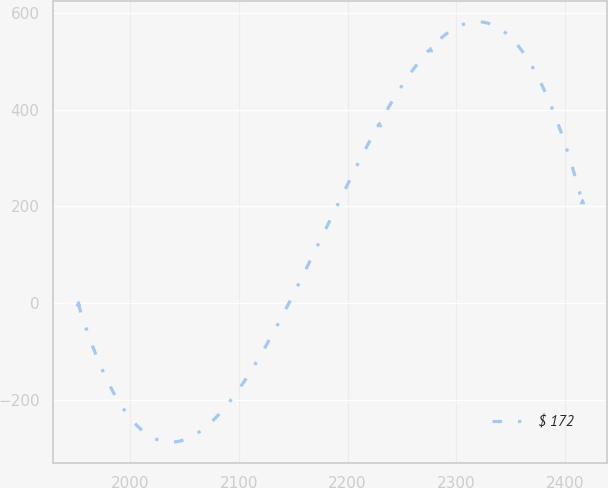<chart> <loc_0><loc_0><loc_500><loc_500><line_chart><ecel><fcel>$ 172<nl><fcel>1952.26<fcel>0<nl><fcel>2229.15<fcel>371.38<nl><fcel>2275.46<fcel>524.88<nl><fcel>2415.38<fcel>211.63<nl></chart> 